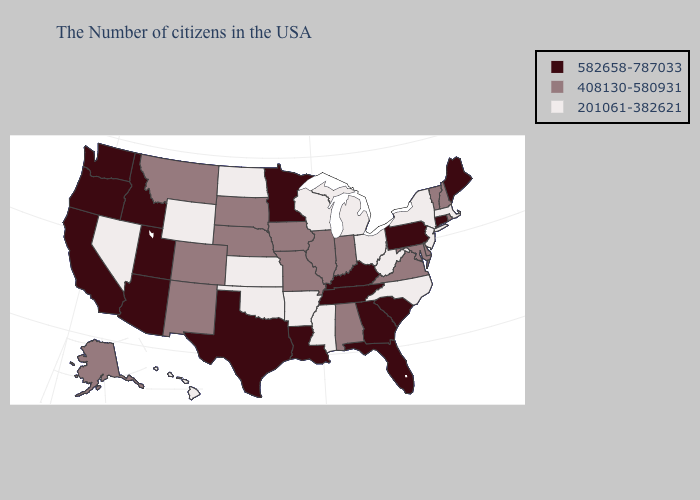What is the value of Wisconsin?
Concise answer only. 201061-382621. Name the states that have a value in the range 201061-382621?
Keep it brief. Massachusetts, New York, New Jersey, North Carolina, West Virginia, Ohio, Michigan, Wisconsin, Mississippi, Arkansas, Kansas, Oklahoma, North Dakota, Wyoming, Nevada, Hawaii. Name the states that have a value in the range 408130-580931?
Keep it brief. Rhode Island, New Hampshire, Vermont, Delaware, Maryland, Virginia, Indiana, Alabama, Illinois, Missouri, Iowa, Nebraska, South Dakota, Colorado, New Mexico, Montana, Alaska. Does Arizona have a higher value than Missouri?
Be succinct. Yes. What is the value of Connecticut?
Quick response, please. 582658-787033. Name the states that have a value in the range 408130-580931?
Be succinct. Rhode Island, New Hampshire, Vermont, Delaware, Maryland, Virginia, Indiana, Alabama, Illinois, Missouri, Iowa, Nebraska, South Dakota, Colorado, New Mexico, Montana, Alaska. What is the value of Missouri?
Short answer required. 408130-580931. Is the legend a continuous bar?
Answer briefly. No. Name the states that have a value in the range 408130-580931?
Give a very brief answer. Rhode Island, New Hampshire, Vermont, Delaware, Maryland, Virginia, Indiana, Alabama, Illinois, Missouri, Iowa, Nebraska, South Dakota, Colorado, New Mexico, Montana, Alaska. What is the value of Maine?
Be succinct. 582658-787033. Which states have the lowest value in the West?
Write a very short answer. Wyoming, Nevada, Hawaii. Name the states that have a value in the range 201061-382621?
Give a very brief answer. Massachusetts, New York, New Jersey, North Carolina, West Virginia, Ohio, Michigan, Wisconsin, Mississippi, Arkansas, Kansas, Oklahoma, North Dakota, Wyoming, Nevada, Hawaii. What is the highest value in the Northeast ?
Short answer required. 582658-787033. What is the highest value in the MidWest ?
Write a very short answer. 582658-787033. Which states hav the highest value in the West?
Answer briefly. Utah, Arizona, Idaho, California, Washington, Oregon. 